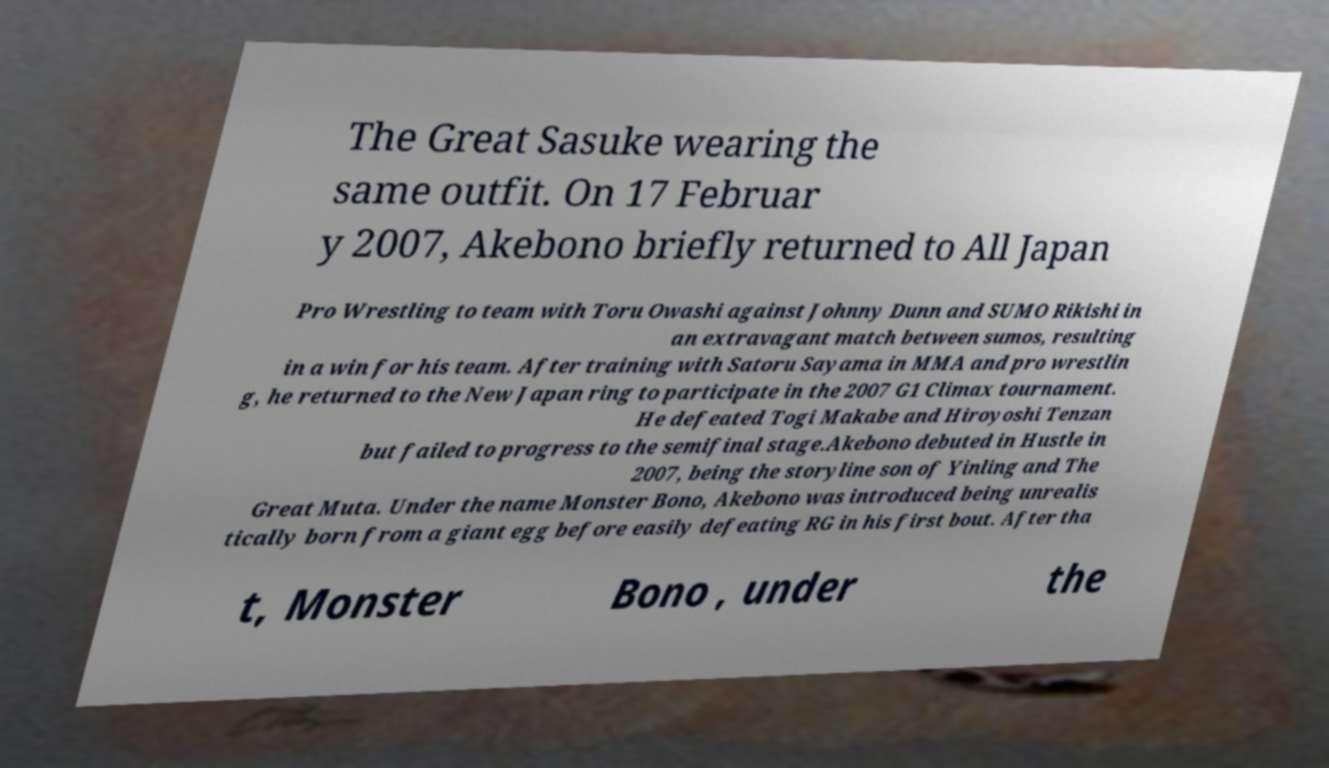Can you read and provide the text displayed in the image?This photo seems to have some interesting text. Can you extract and type it out for me? The Great Sasuke wearing the same outfit. On 17 Februar y 2007, Akebono briefly returned to All Japan Pro Wrestling to team with Toru Owashi against Johnny Dunn and SUMO Rikishi in an extravagant match between sumos, resulting in a win for his team. After training with Satoru Sayama in MMA and pro wrestlin g, he returned to the New Japan ring to participate in the 2007 G1 Climax tournament. He defeated Togi Makabe and Hiroyoshi Tenzan but failed to progress to the semifinal stage.Akebono debuted in Hustle in 2007, being the storyline son of Yinling and The Great Muta. Under the name Monster Bono, Akebono was introduced being unrealis tically born from a giant egg before easily defeating RG in his first bout. After tha t, Monster Bono , under the 